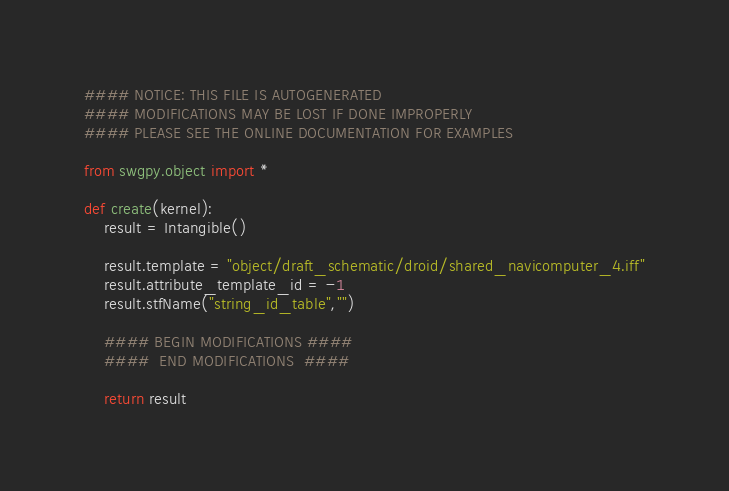Convert code to text. <code><loc_0><loc_0><loc_500><loc_500><_Python_>#### NOTICE: THIS FILE IS AUTOGENERATED
#### MODIFICATIONS MAY BE LOST IF DONE IMPROPERLY
#### PLEASE SEE THE ONLINE DOCUMENTATION FOR EXAMPLES

from swgpy.object import *	

def create(kernel):
	result = Intangible()

	result.template = "object/draft_schematic/droid/shared_navicomputer_4.iff"
	result.attribute_template_id = -1
	result.stfName("string_id_table","")		
	
	#### BEGIN MODIFICATIONS ####
	####  END MODIFICATIONS  ####
	
	return result</code> 